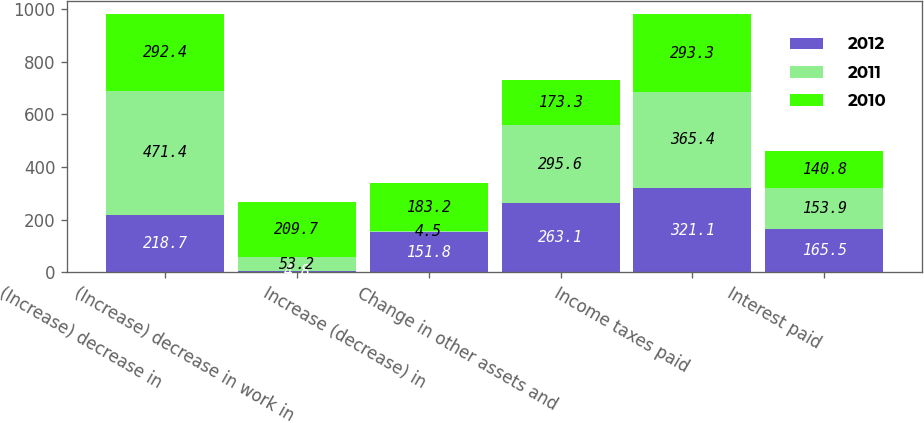Convert chart. <chart><loc_0><loc_0><loc_500><loc_500><stacked_bar_chart><ecel><fcel>(Increase) decrease in<fcel>(Increase) decrease in work in<fcel>Increase (decrease) in<fcel>Change in other assets and<fcel>Income taxes paid<fcel>Interest paid<nl><fcel>2012<fcel>218.7<fcel>4.8<fcel>151.8<fcel>263.1<fcel>321.1<fcel>165.5<nl><fcel>2011<fcel>471.4<fcel>53.2<fcel>4.5<fcel>295.6<fcel>365.4<fcel>153.9<nl><fcel>2010<fcel>292.4<fcel>209.7<fcel>183.2<fcel>173.3<fcel>293.3<fcel>140.8<nl></chart> 